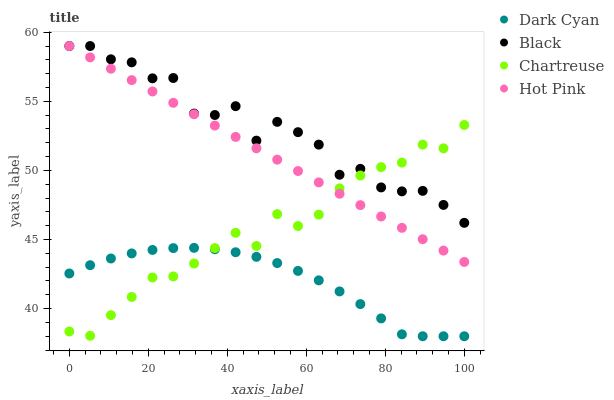Does Dark Cyan have the minimum area under the curve?
Answer yes or no. Yes. Does Black have the maximum area under the curve?
Answer yes or no. Yes. Does Chartreuse have the minimum area under the curve?
Answer yes or no. No. Does Chartreuse have the maximum area under the curve?
Answer yes or no. No. Is Hot Pink the smoothest?
Answer yes or no. Yes. Is Black the roughest?
Answer yes or no. Yes. Is Chartreuse the smoothest?
Answer yes or no. No. Is Chartreuse the roughest?
Answer yes or no. No. Does Dark Cyan have the lowest value?
Answer yes or no. Yes. Does Chartreuse have the lowest value?
Answer yes or no. No. Does Black have the highest value?
Answer yes or no. Yes. Does Chartreuse have the highest value?
Answer yes or no. No. Is Dark Cyan less than Black?
Answer yes or no. Yes. Is Black greater than Dark Cyan?
Answer yes or no. Yes. Does Chartreuse intersect Black?
Answer yes or no. Yes. Is Chartreuse less than Black?
Answer yes or no. No. Is Chartreuse greater than Black?
Answer yes or no. No. Does Dark Cyan intersect Black?
Answer yes or no. No. 